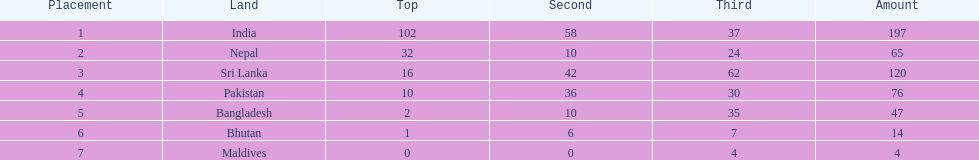Who has won the most bronze medals? Sri Lanka. 